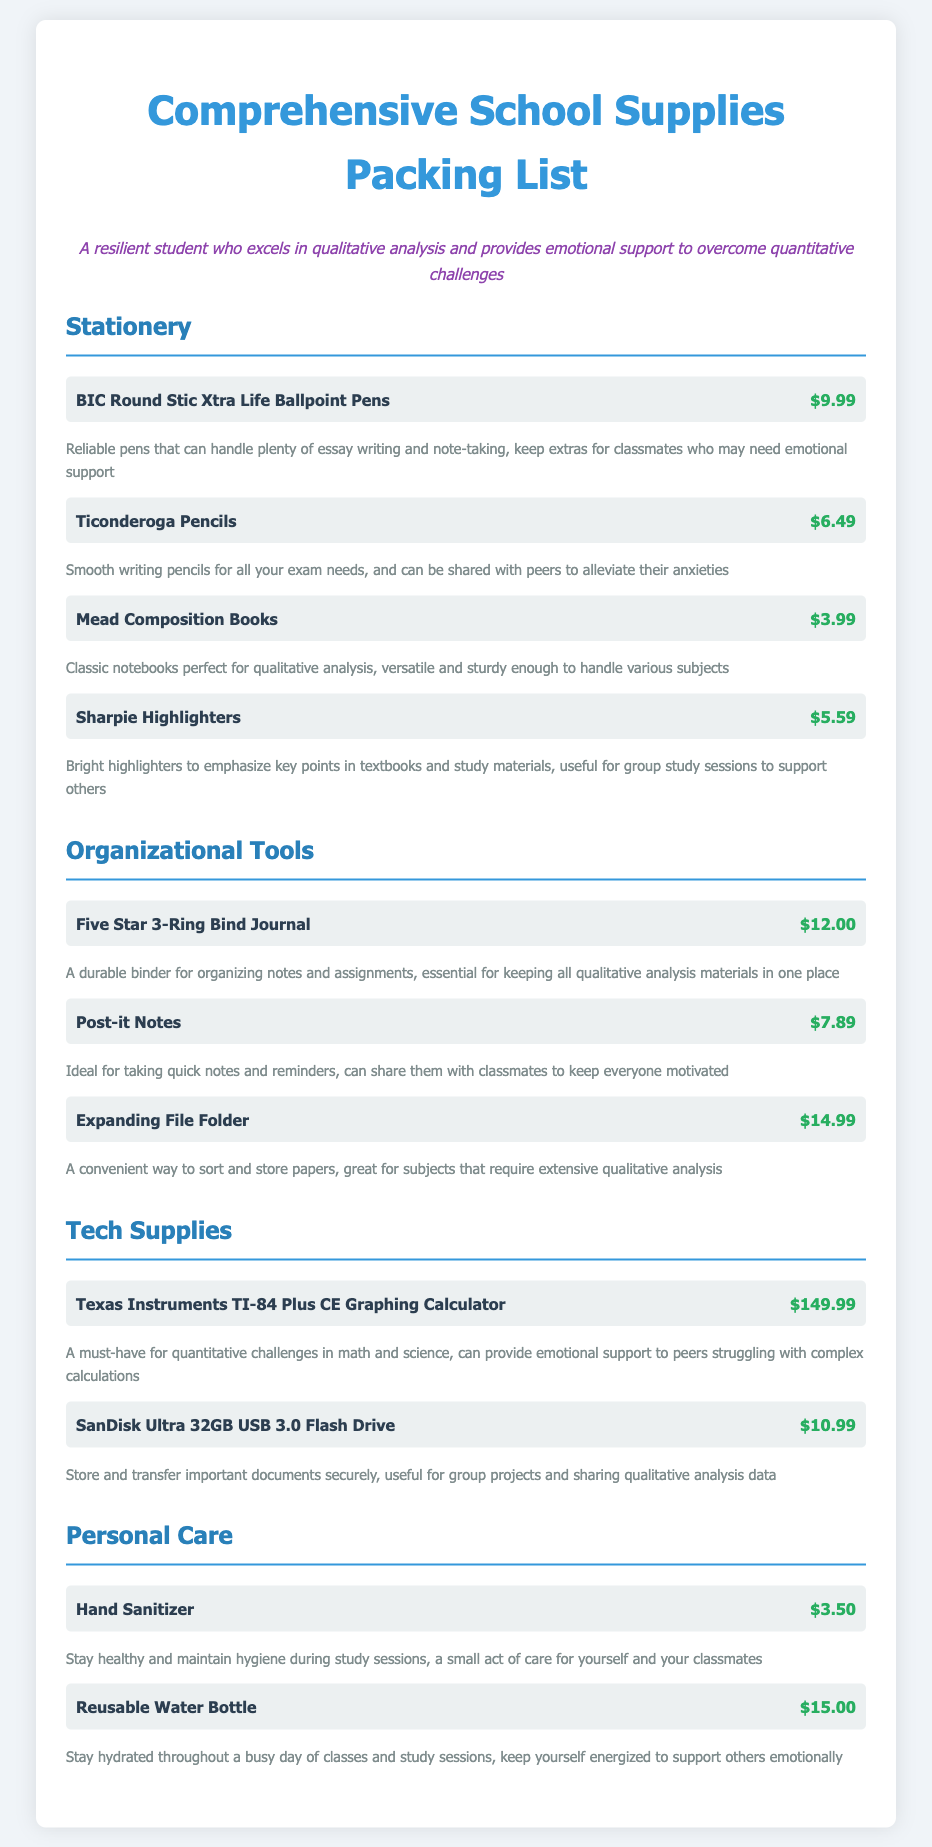what is the price of BIC Round Stic Xtra Life Ballpoint Pens? The price for the BIC Round Stic Xtra Life Ballpoint Pens is listed in the stationery category.
Answer: $9.99 how many items are in the Organizational Tools category? The Organizational Tools category contains three items listed under it.
Answer: 3 what is the total price of all items in the Stationery category? The total price is calculated by adding all the prices of the items in the Stationery category, which sums up to $25.06.
Answer: $25.06 which item is the most expensive in the Tech Supplies category? The most expensive item in the Tech Supplies category is identified by comparing the prices of the listed items.
Answer: Texas Instruments TI-84 Plus CE Graphing Calculator what is the item description for Sharpie Highlighters? The description for Sharpie Highlighters can be found below its price in the stationery section.
Answer: Bright highlighters to emphasize key points in textbooks and study materials, useful for group study sessions to support others how much does a Reusable Water Bottle cost? The Reusable Water Bottle price can be found under the Personal Care category.
Answer: $15.00 what is the main purpose of Post-it Notes according to the document? The purpose of Post-it Notes is described in the item description in the Organizational Tools category.
Answer: Ideal for taking quick notes and reminders, can share them with classmates to keep everyone motivated which category has the most items listed? By comparing the number of items in each category, we can determine which has the most.
Answer: Stationery 